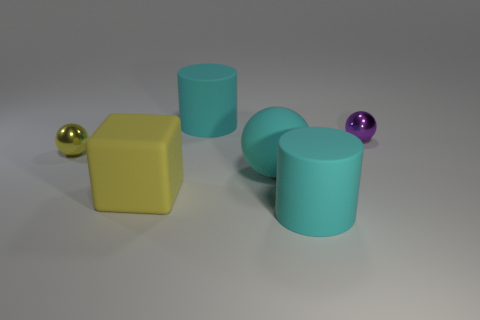Add 3 matte cylinders. How many objects exist? 9 Subtract all blocks. How many objects are left? 5 Add 1 yellow metallic objects. How many yellow metallic objects are left? 2 Add 4 large cyan rubber objects. How many large cyan rubber objects exist? 7 Subtract 0 gray blocks. How many objects are left? 6 Subtract all small purple objects. Subtract all large cyan cylinders. How many objects are left? 3 